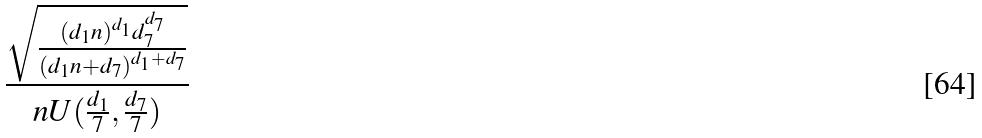Convert formula to latex. <formula><loc_0><loc_0><loc_500><loc_500>\frac { \sqrt { \frac { ( d _ { 1 } n ) ^ { d _ { 1 } } d _ { 7 } ^ { d _ { 7 } } } { ( d _ { 1 } n + d _ { 7 } ) ^ { d _ { 1 } + d _ { 7 } } } } } { n U ( \frac { d _ { 1 } } { 7 } , \frac { d _ { 7 } } { 7 } ) }</formula> 